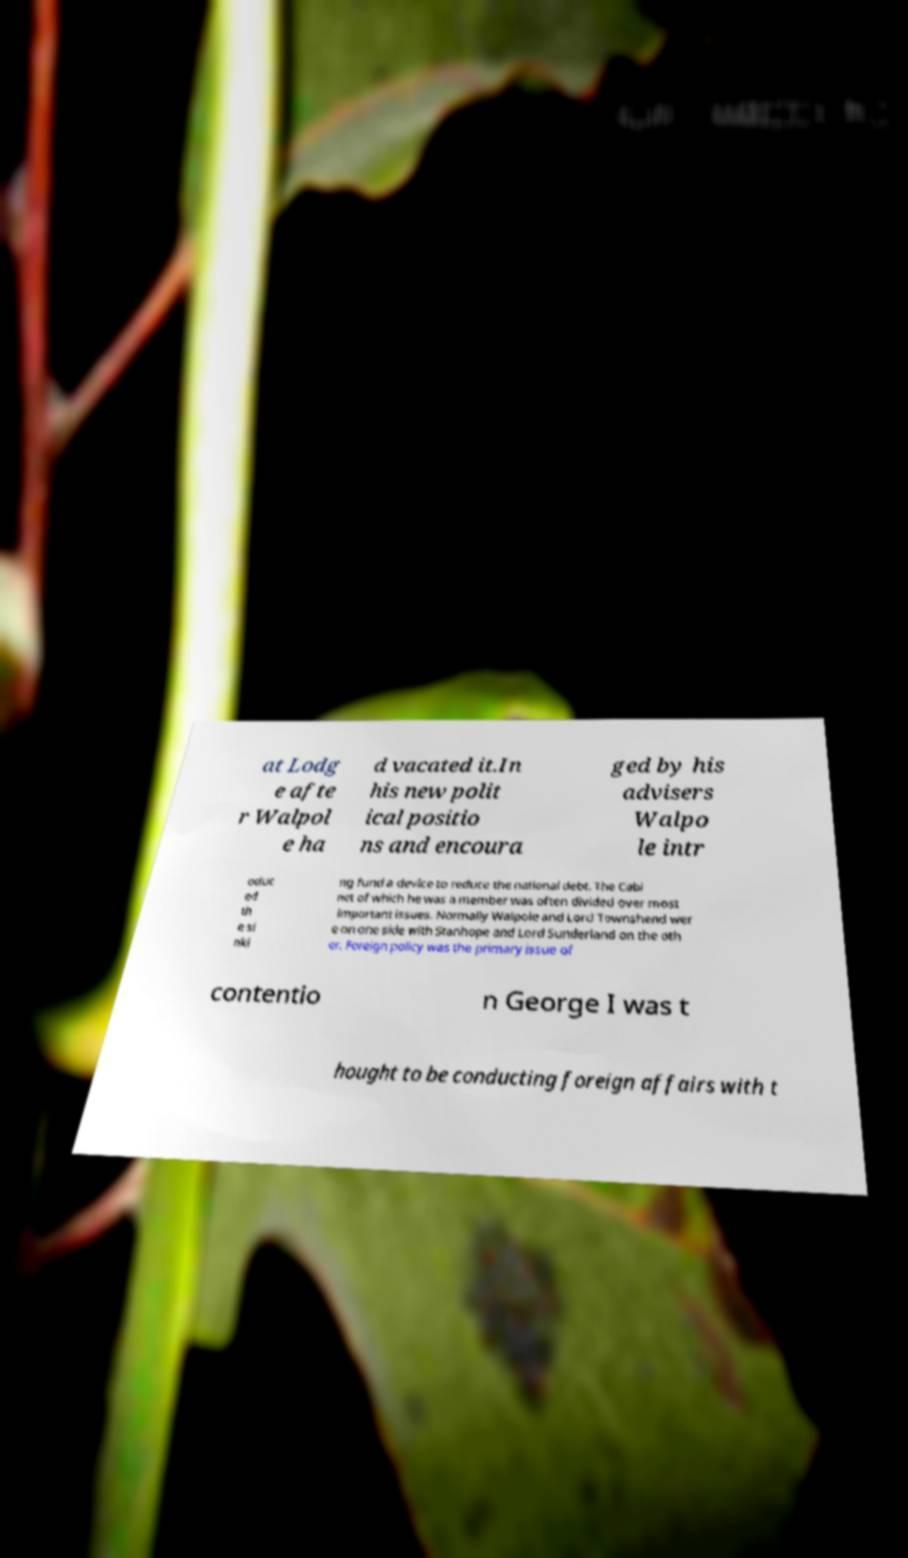For documentation purposes, I need the text within this image transcribed. Could you provide that? at Lodg e afte r Walpol e ha d vacated it.In his new polit ical positio ns and encoura ged by his advisers Walpo le intr oduc ed th e si nki ng fund a device to reduce the national debt. The Cabi net of which he was a member was often divided over most important issues. Normally Walpole and Lord Townshend wer e on one side with Stanhope and Lord Sunderland on the oth er. Foreign policy was the primary issue of contentio n George I was t hought to be conducting foreign affairs with t 